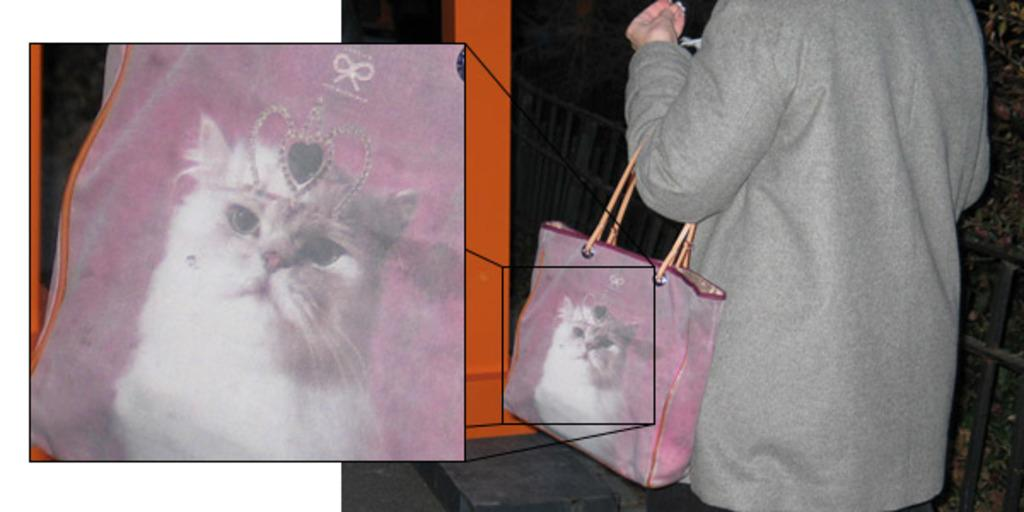What is present in the image? There is a person in the image. What is the person doing in the image? The person is carrying a bag. Can you describe the bag in the image? The bag has a cat picture on it. What type of tank is visible in the image? There is no tank present in the image. What musical instrument is the person playing in the image? The image does not show the person playing any musical instrument. 